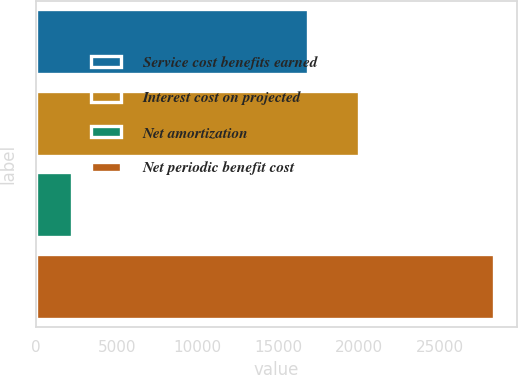<chart> <loc_0><loc_0><loc_500><loc_500><bar_chart><fcel>Service cost benefits earned<fcel>Interest cost on projected<fcel>Net amortization<fcel>Net periodic benefit cost<nl><fcel>16825<fcel>19991<fcel>2239<fcel>28351<nl></chart> 